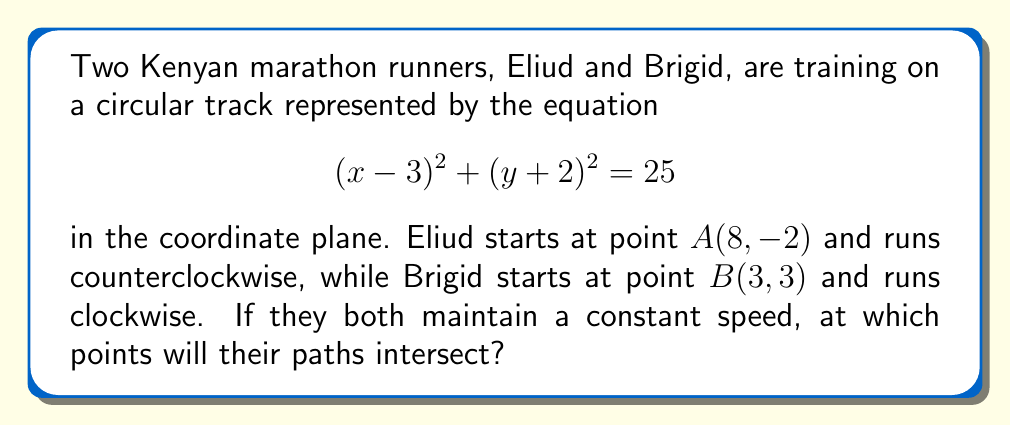Give your solution to this math problem. To solve this problem, we need to follow these steps:

1) First, we need to verify that both starting points are on the circular track. We can do this by substituting their coordinates into the equation of the circle:

   For point A: $(8-3)^2 + (-2+2)^2 = 5^2 + 0^2 = 25$
   For point B: $(3-3)^2 + (3+2)^2 = 0^2 + 5^2 = 25$

   Both equations equal 25, confirming that A and B are on the circle.

2) The runners will intersect at two points: their starting points and the point directly opposite on the circle.

3) To find the point opposite to the midpoint of A and B, we need to:
   a) Find the midpoint M of A and B
   b) Find the center of the circle C
   c) Extend the line CM to intersect the circle at the opposite point

4) The midpoint M of A and B is:
   $$M = (\frac{x_A + x_B}{2}, \frac{y_A + y_B}{2}) = (\frac{8 + 3}{2}, \frac{-2 + 3}{2}) = (5.5, 0.5)$$

5) The center of the circle C is (3, -2) as given in the equation.

6) The vector from C to M is:
   $$\vec{CM} = (5.5 - 3, 0.5 - (-2)) = (2.5, 2.5)$$

7) To find the opposite point P, we extend this vector to twice its length from the center:
   $$\vec{CP} = 2\vec{CM} = (5, 5)$$

8) Therefore, the coordinates of P are:
   $$P = (3 + 5, -2 + 5) = (8, 3)$$

9) We can verify that P is on the circle:
   $$(8-3)^2 + (3+2)^2 = 5^2 + 5^2 = 50 = 25 + 25 = 25 \cdot 2$$

   This confirms that P is on the circle.

Thus, the runners' paths will intersect at points A(8, -2) and P(8, 3).
Answer: The paths of the two runners intersect at points (8, -2) and (8, 3). 